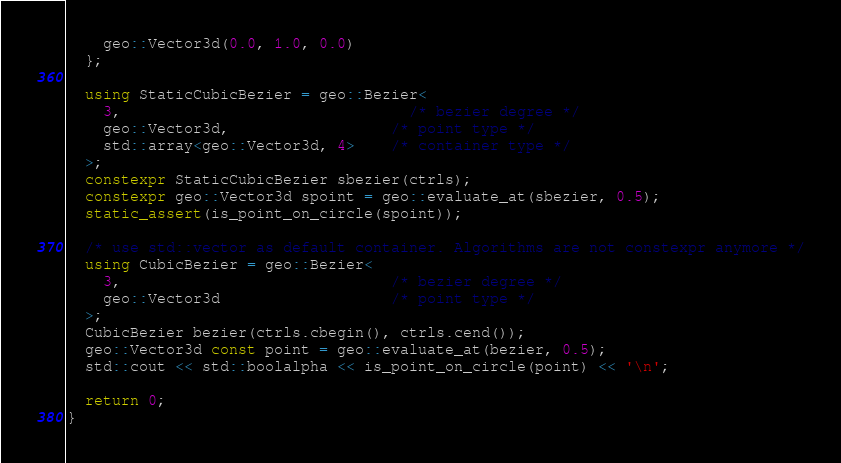Convert code to text. <code><loc_0><loc_0><loc_500><loc_500><_C++_>    geo::Vector3d(0.0, 1.0, 0.0)
  };

  using StaticCubicBezier = geo::Bezier<
    3,                                /* bezier degree */
    geo::Vector3d,                  /* point type */
    std::array<geo::Vector3d, 4>    /* container type */
  >;
  constexpr StaticCubicBezier sbezier(ctrls);
  constexpr geo::Vector3d spoint = geo::evaluate_at(sbezier, 0.5);
  static_assert(is_point_on_circle(spoint));

  /* use std::vector as default container. Algorithms are not constexpr anymore */
  using CubicBezier = geo::Bezier<
    3,                              /* bezier degree */
    geo::Vector3d                   /* point type */
  >;
  CubicBezier bezier(ctrls.cbegin(), ctrls.cend());
  geo::Vector3d const point = geo::evaluate_at(bezier, 0.5);
  std::cout << std::boolalpha << is_point_on_circle(point) << '\n';

  return 0;
}
</code> 